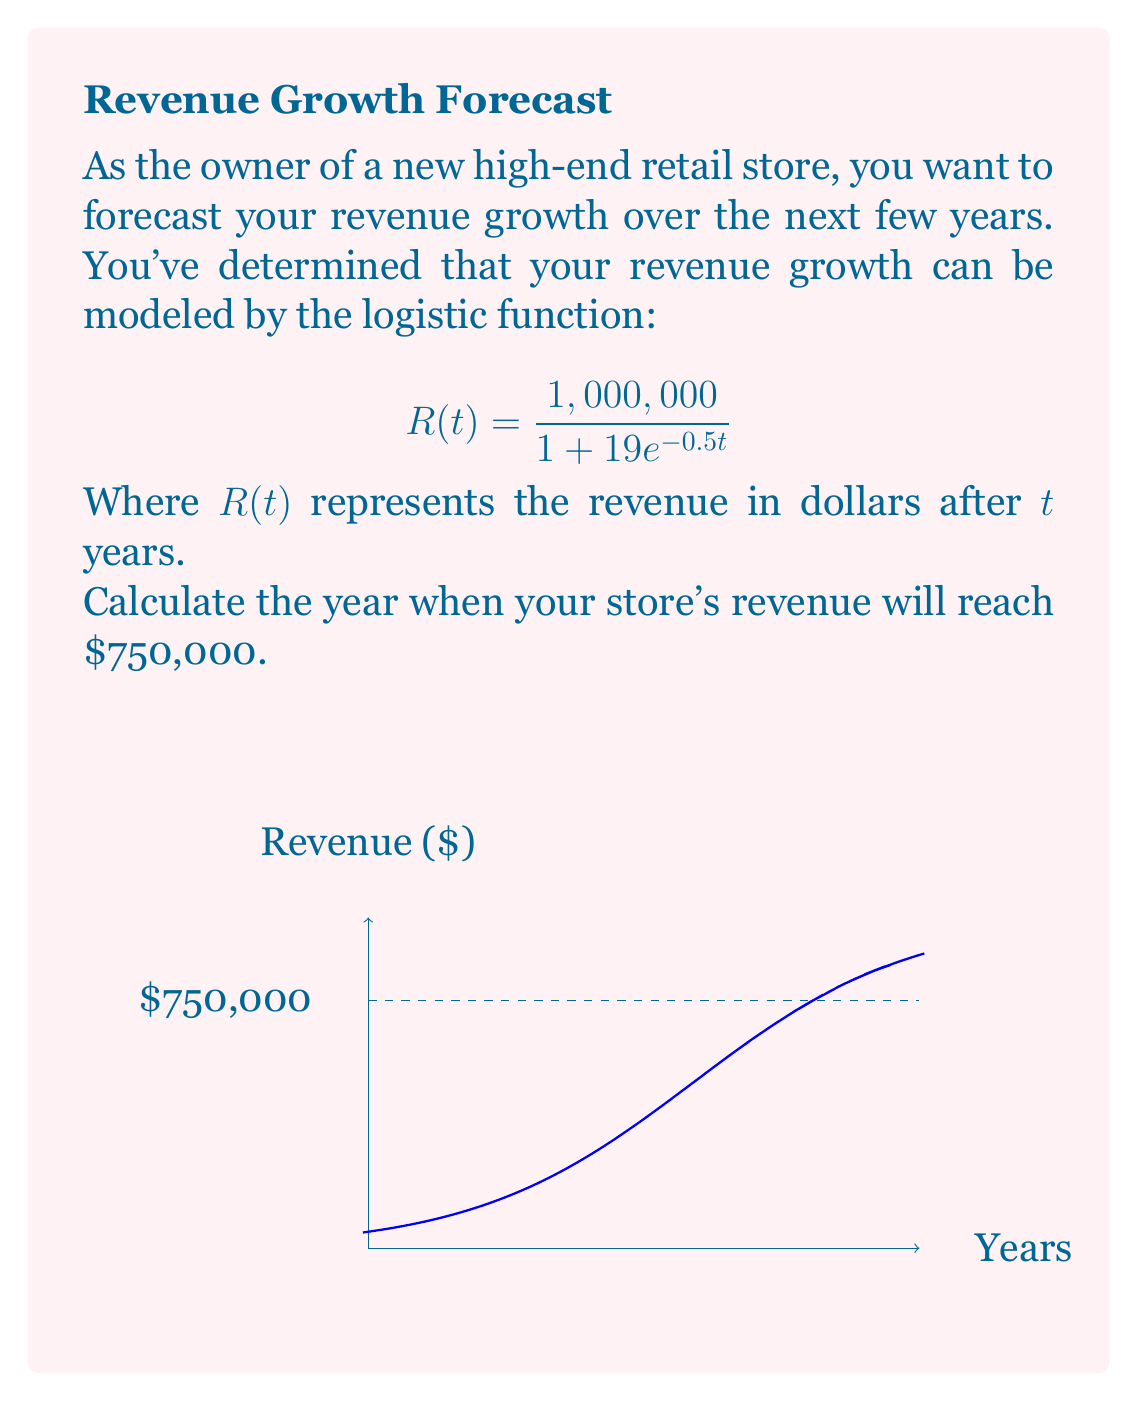Give your solution to this math problem. Let's approach this step-by-step:

1) We need to find $t$ when $R(t) = 750,000$. So, we set up the equation:

   $$750,000 = \frac{1,000,000}{1 + 19e^{-0.5t}}$$

2) Multiply both sides by $(1 + 19e^{-0.5t})$:

   $$750,000(1 + 19e^{-0.5t}) = 1,000,000$$

3) Expand the left side:

   $$750,000 + 14,250,000e^{-0.5t} = 1,000,000$$

4) Subtract 750,000 from both sides:

   $$14,250,000e^{-0.5t} = 250,000$$

5) Divide both sides by 14,250,000:

   $$e^{-0.5t} = \frac{250,000}{14,250,000} = \frac{1}{57}$$

6) Take the natural log of both sides:

   $$-0.5t = \ln(\frac{1}{57})$$

7) Divide both sides by -0.5:

   $$t = -\frac{\ln(\frac{1}{57})}{0.5} = \frac{\ln(57)}{0.5}$$

8) Calculate the final value:

   $$t \approx 8.14$$

Therefore, the revenue will reach $750,000 after approximately 8.14 years.
Answer: 8.14 years 